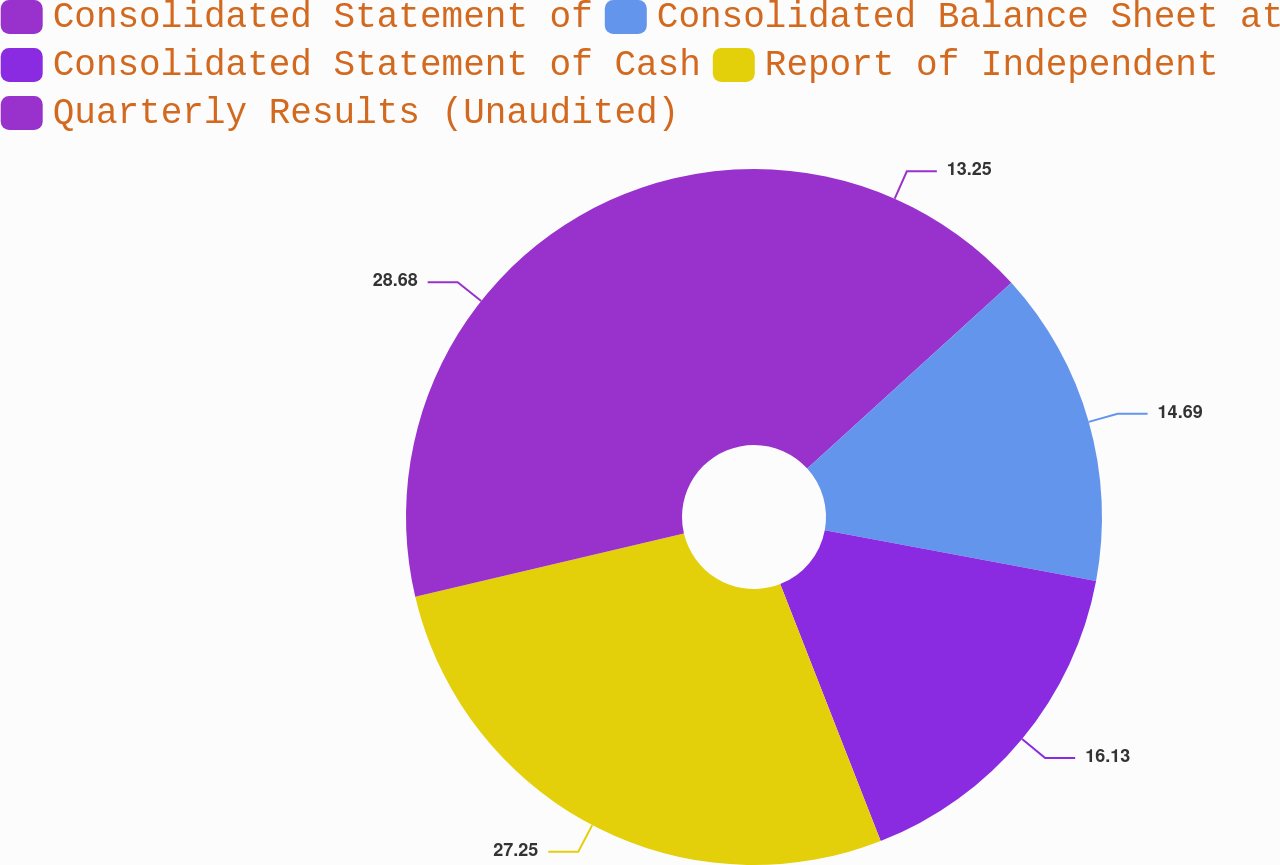Convert chart. <chart><loc_0><loc_0><loc_500><loc_500><pie_chart><fcel>Consolidated Statement of<fcel>Consolidated Balance Sheet at<fcel>Consolidated Statement of Cash<fcel>Report of Independent<fcel>Quarterly Results (Unaudited)<nl><fcel>13.25%<fcel>14.69%<fcel>16.13%<fcel>27.25%<fcel>28.68%<nl></chart> 